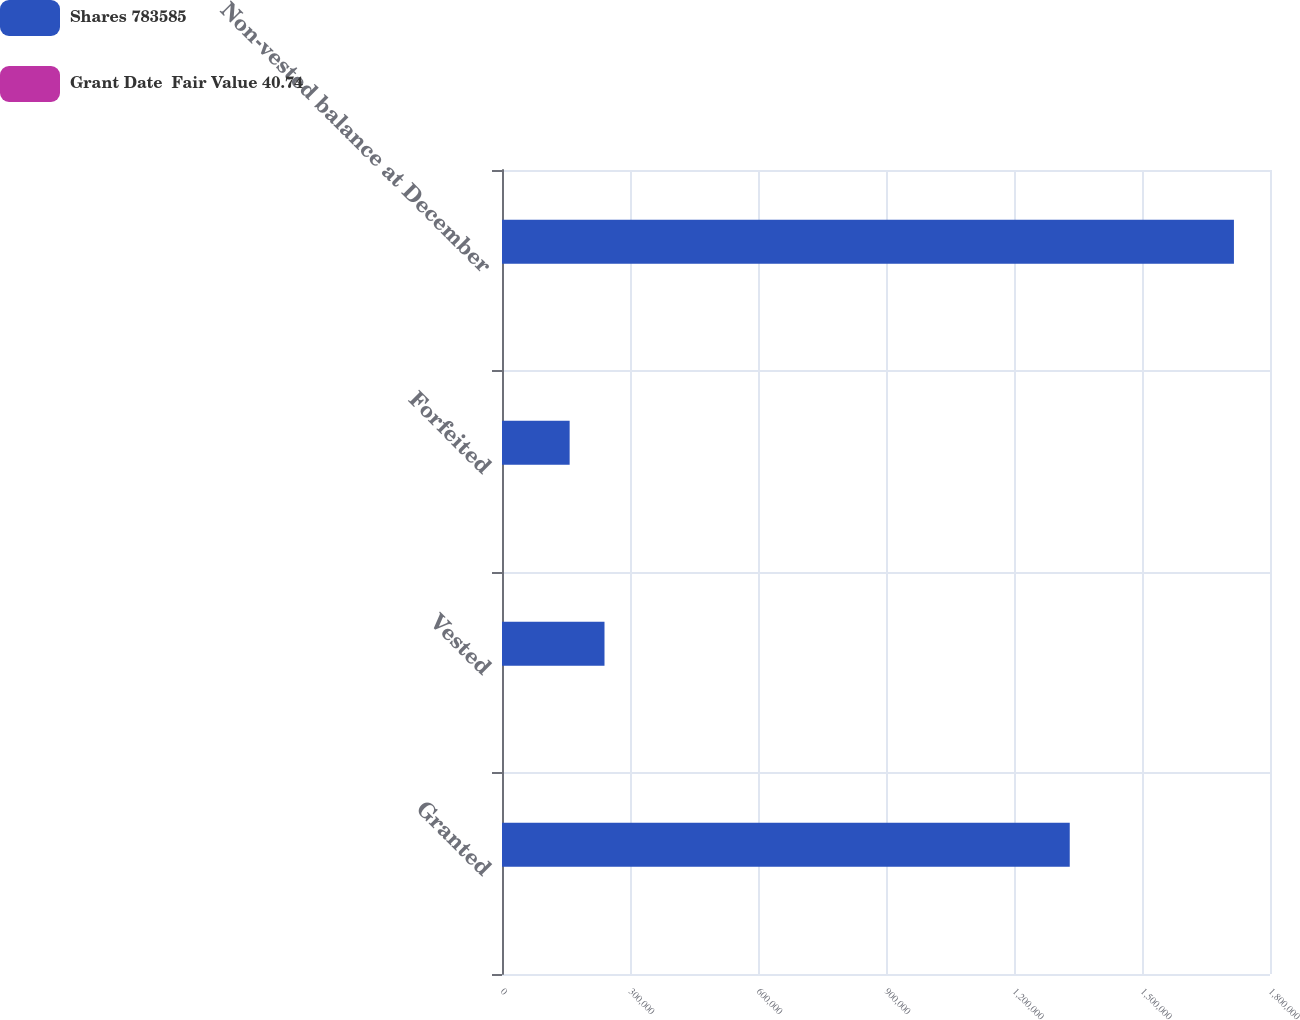Convert chart. <chart><loc_0><loc_0><loc_500><loc_500><stacked_bar_chart><ecel><fcel>Granted<fcel>Vested<fcel>Forfeited<fcel>Non-vested balance at December<nl><fcel>Shares 783585<fcel>1.33066e+06<fcel>240221<fcel>158543<fcel>1.71548e+06<nl><fcel>Grant Date  Fair Value 40.74<fcel>30.3<fcel>41.23<fcel>34.72<fcel>33.14<nl></chart> 